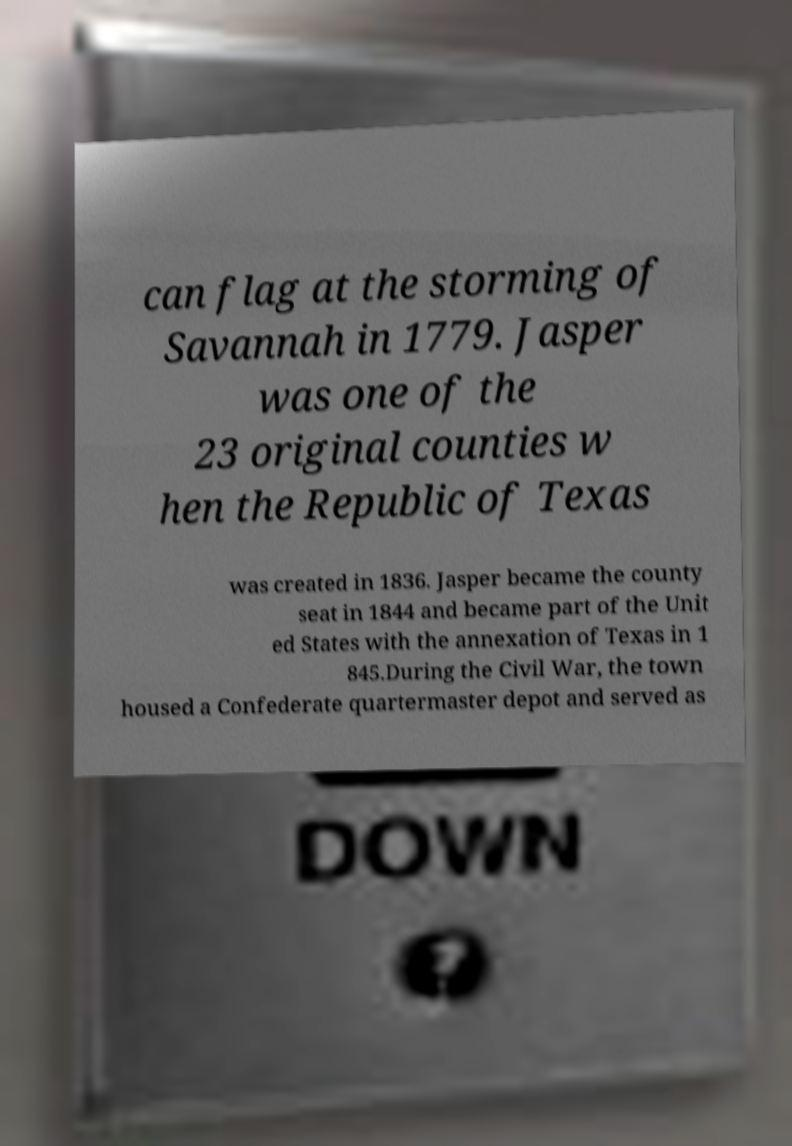Can you accurately transcribe the text from the provided image for me? can flag at the storming of Savannah in 1779. Jasper was one of the 23 original counties w hen the Republic of Texas was created in 1836. Jasper became the county seat in 1844 and became part of the Unit ed States with the annexation of Texas in 1 845.During the Civil War, the town housed a Confederate quartermaster depot and served as 